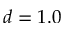<formula> <loc_0><loc_0><loc_500><loc_500>d = 1 . 0</formula> 